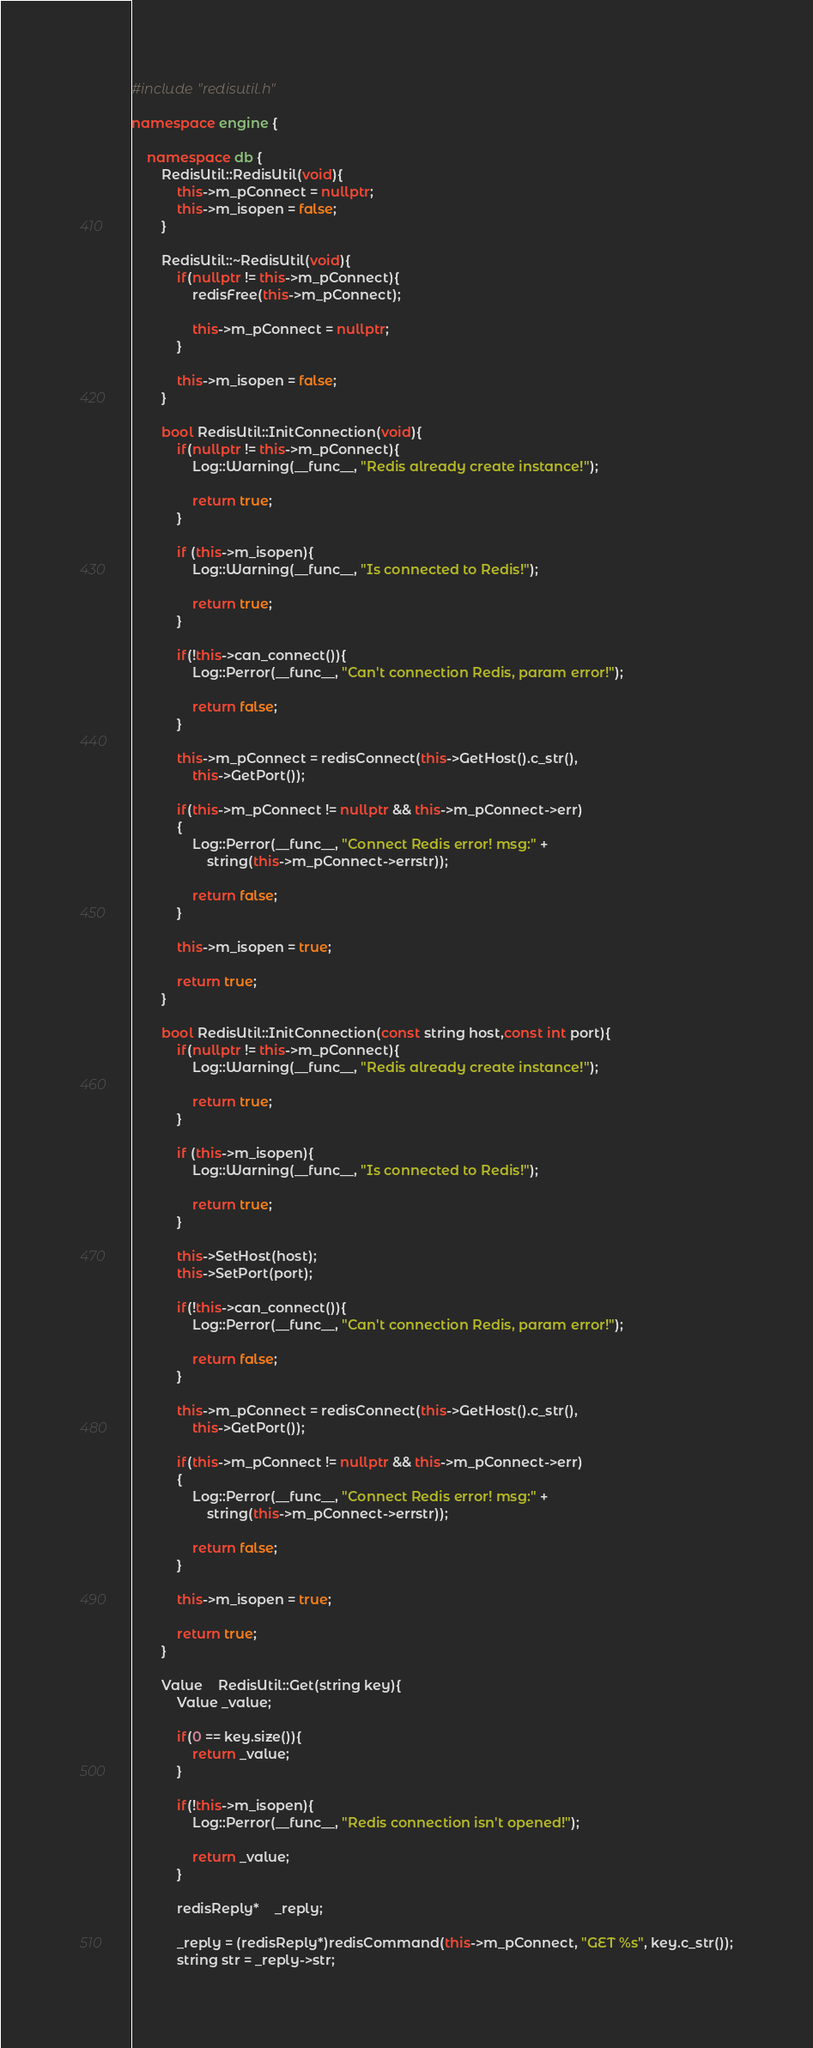Convert code to text. <code><loc_0><loc_0><loc_500><loc_500><_C++_>#include "redisutil.h"

namespace engine {

	namespace db {
		RedisUtil::RedisUtil(void){
			this->m_pConnect = nullptr;
			this->m_isopen = false;
		}

		RedisUtil::~RedisUtil(void){
			if(nullptr != this->m_pConnect){
				redisFree(this->m_pConnect);

				this->m_pConnect = nullptr;
			}

			this->m_isopen = false;
		}

		bool RedisUtil::InitConnection(void){
			if(nullptr != this->m_pConnect){
				Log::Warning(__func__, "Redis already create instance!");

				return true;
			}

			if (this->m_isopen){
			 	Log::Warning(__func__, "Is connected to Redis!");

	            return true;    
	        } 

	        if(!this->can_connect()){
	        	Log::Perror(__func__, "Can't connection Redis, param error!");

	        	return false;
	        }

			this->m_pConnect = redisConnect(this->GetHost().c_str(), 
				this->GetPort());

	        if(this->m_pConnect != nullptr && this->m_pConnect->err)
	        {
	            Log::Perror(__func__, "Connect Redis error! msg:" + 
	            	string(this->m_pConnect->errstr));

	            return false;
	        }

	        this->m_isopen = true;

	        return true;
		}

		bool RedisUtil::InitConnection(const string host,const int port){
			if(nullptr != this->m_pConnect){
				Log::Warning(__func__, "Redis already create instance!");

				return true;
			}

			if (this->m_isopen){
			 	Log::Warning(__func__, "Is connected to Redis!");

	            return true;    
	        } 

	        this->SetHost(host);
	        this->SetPort(port);

	        if(!this->can_connect()){
	        	Log::Perror(__func__, "Can't connection Redis, param error!");

	        	return false;
	        }

	        this->m_pConnect = redisConnect(this->GetHost().c_str(), 
				this->GetPort());

	        if(this->m_pConnect != nullptr && this->m_pConnect->err)
	        {
	            Log::Perror(__func__, "Connect Redis error! msg:" + 
	            	string(this->m_pConnect->errstr));

	            return false;
	        }

	        this->m_isopen = true;

	        return true;
		}

		Value 	RedisUtil::Get(string key){
			Value _value;
			
			if(0 == key.size()){
				return _value;
			}

			if(!this->m_isopen){
				Log::Perror(__func__, "Redis connection isn't opened!");

				return _value;
			}

			redisReply* 	_reply;	

			_reply = (redisReply*)redisCommand(this->m_pConnect, "GET %s", key.c_str());
	        string str = _reply->str;
</code> 